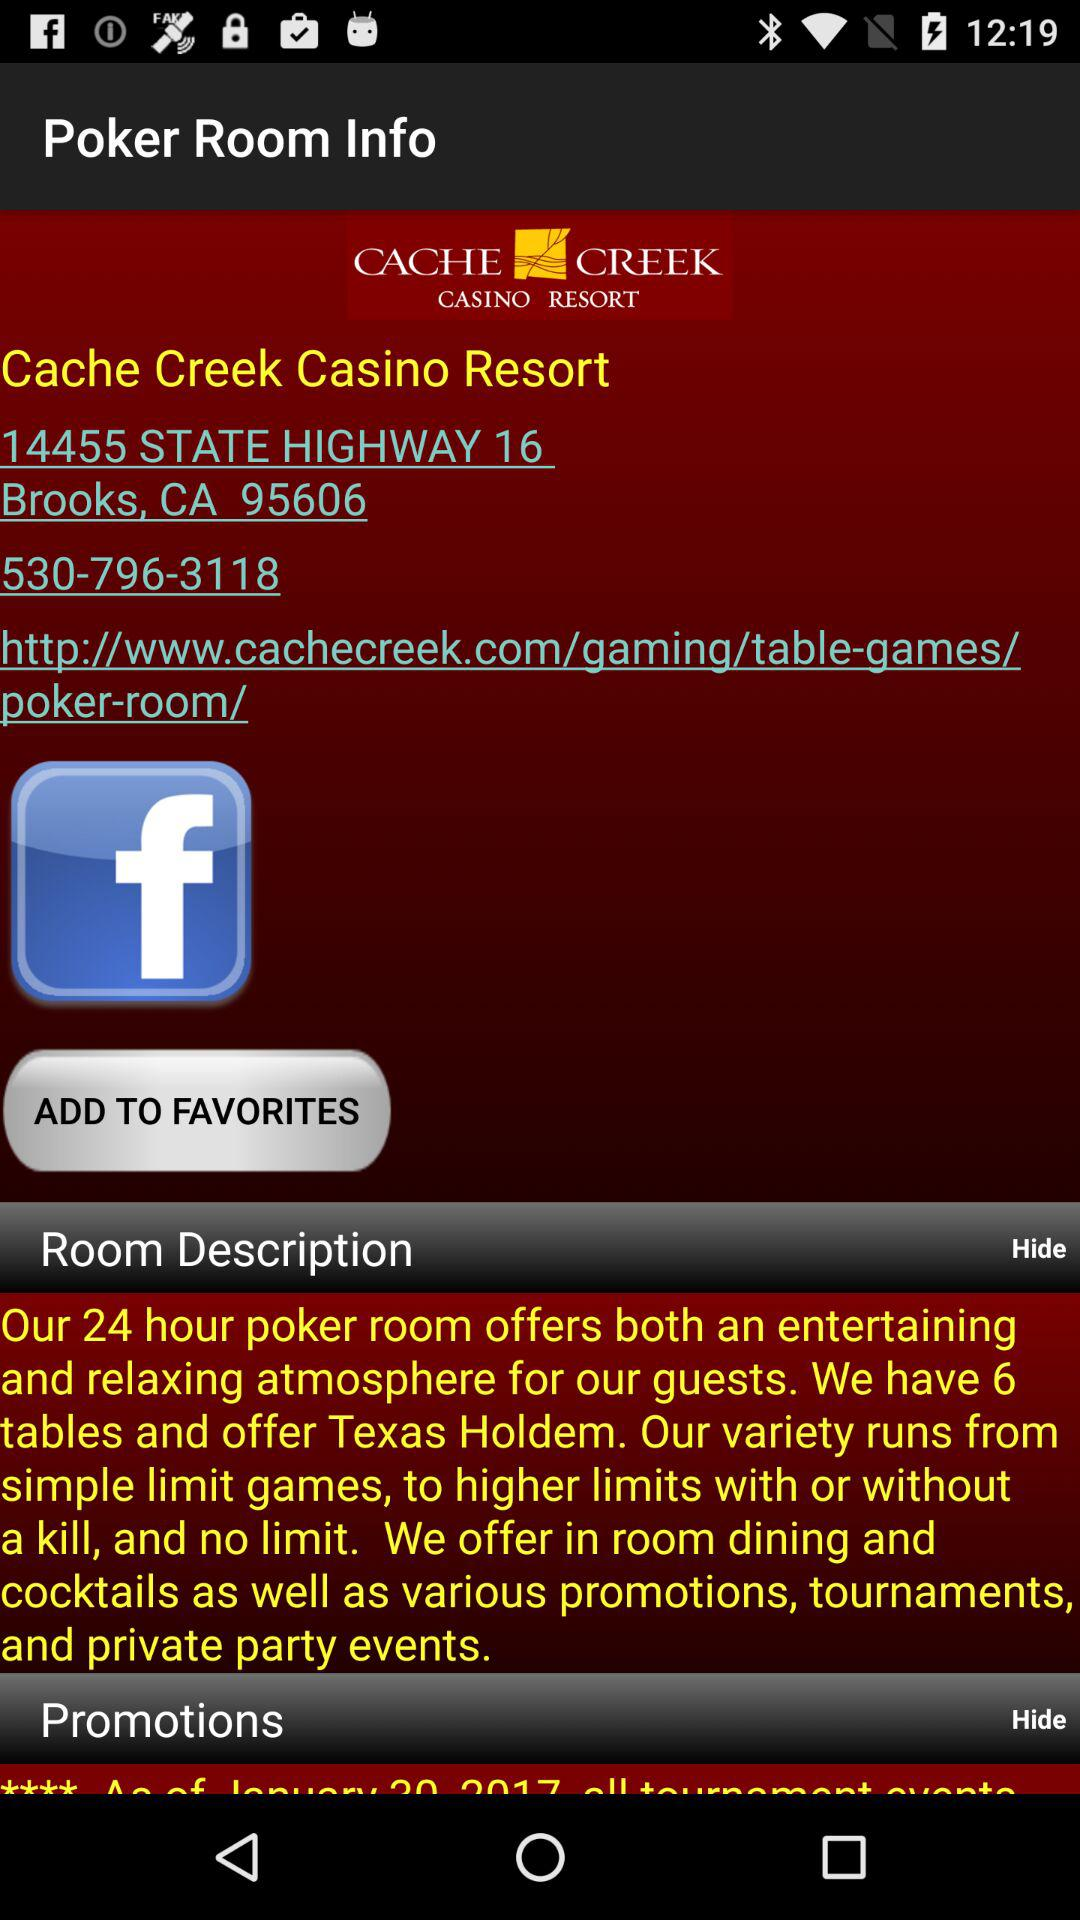What is the location? The location is 14455 State Highway 16, Brooks, CA 95606. 